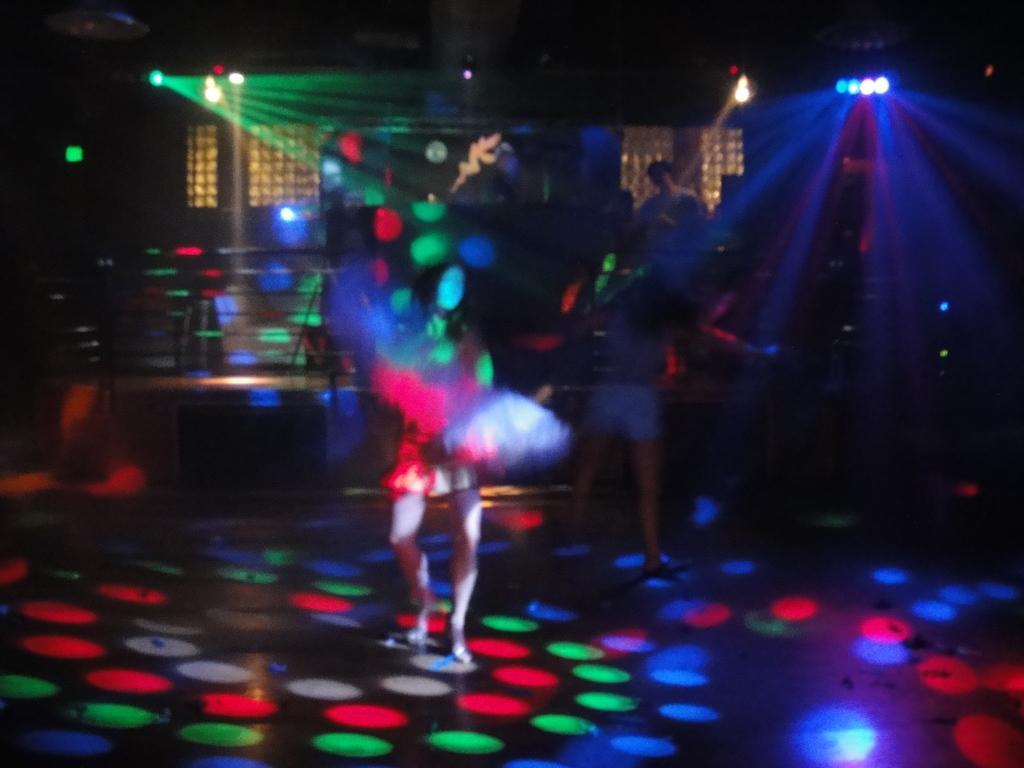What is the main action being performed by the person in the image? There is a person dancing in the image. Can you describe the setting in which the person is dancing? There are other people and musical instruments in the background of the image. What additional visual elements are present in the image? There are colorful lights visible in the image. What type of dress is the person wearing while holding sticks in the image? There is no dress or sticks present in the image; the person is dancing, and there are other people, musical instruments, and colorful lights visible in the background. 